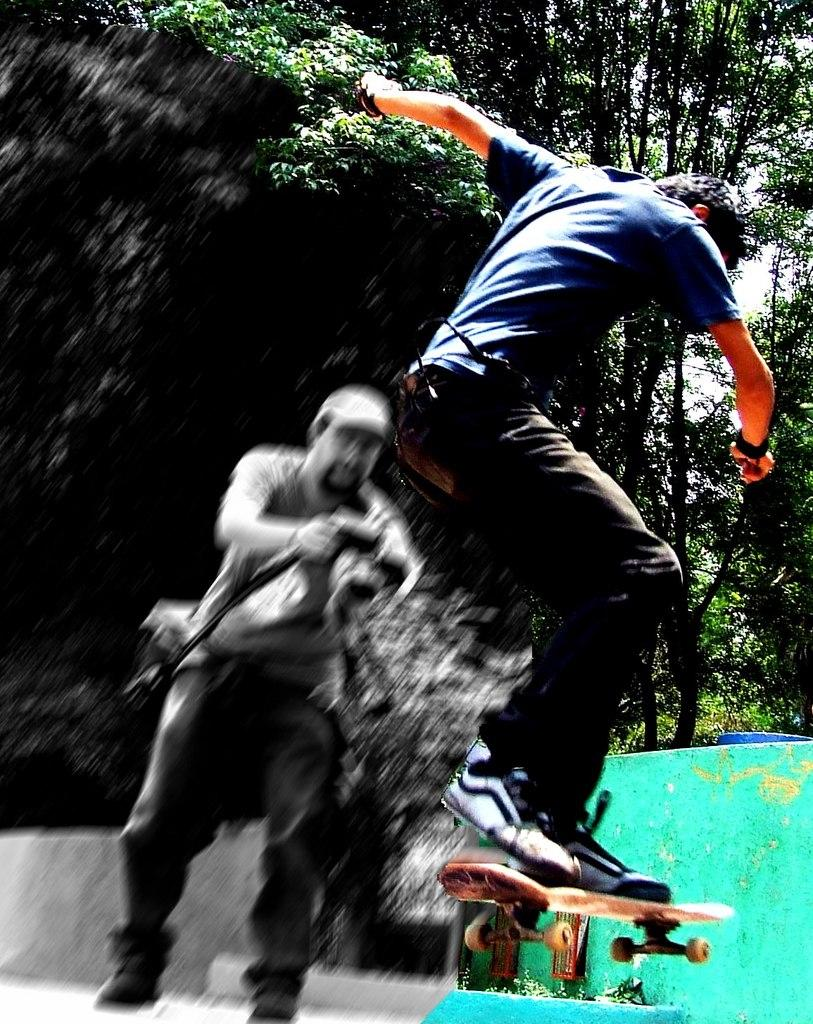How many people are in the image? There are two people in the image. What is one person doing in the image? One person is holding a camera. What is the other person doing in the image? The other person is on a skateboard in the air. What can be seen in the background of the image? There are trees visible in the background of the image. What type of lamp is on the skateboard in the image? There is no lamp present in the image; the person on the skateboard is in the air. 